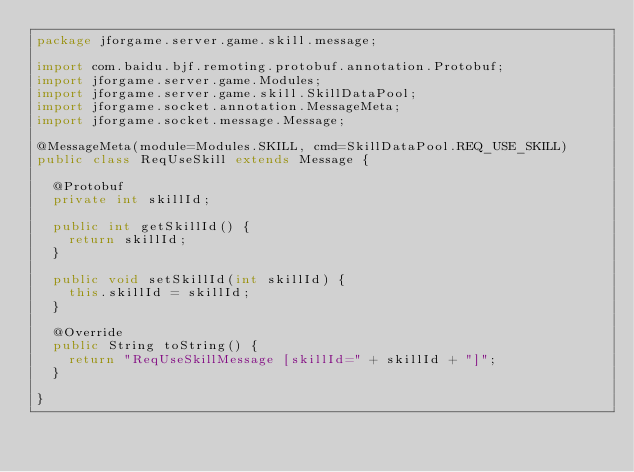<code> <loc_0><loc_0><loc_500><loc_500><_Java_>package jforgame.server.game.skill.message;

import com.baidu.bjf.remoting.protobuf.annotation.Protobuf;
import jforgame.server.game.Modules;
import jforgame.server.game.skill.SkillDataPool;
import jforgame.socket.annotation.MessageMeta;
import jforgame.socket.message.Message;

@MessageMeta(module=Modules.SKILL, cmd=SkillDataPool.REQ_USE_SKILL)
public class ReqUseSkill extends Message {

	@Protobuf
	private int skillId;

	public int getSkillId() {
		return skillId;
	}

	public void setSkillId(int skillId) {
		this.skillId = skillId;
	}

	@Override
	public String toString() {
		return "ReqUseSkillMessage [skillId=" + skillId + "]";
	}

}
</code> 